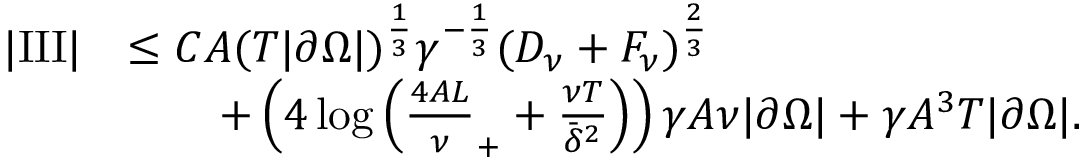<formula> <loc_0><loc_0><loc_500><loc_500>\begin{array} { r l } { | I I I | } & { \leq C A ( T | \partial \Omega | ) ^ { \frac { 1 } { 3 } } \gamma ^ { - \frac { 1 } { 3 } } ( D _ { \nu } + F _ { \nu } ) ^ { \frac { 2 } { 3 } } } \\ & { \quad + \left ( 4 \log \left ( \frac { 4 A L } \nu _ { + } + \frac { \nu T } { \bar { \delta } ^ { 2 } } \right ) \right ) \gamma A \nu | \partial \Omega | + \gamma A ^ { 3 } T | \partial \Omega | . } \end{array}</formula> 